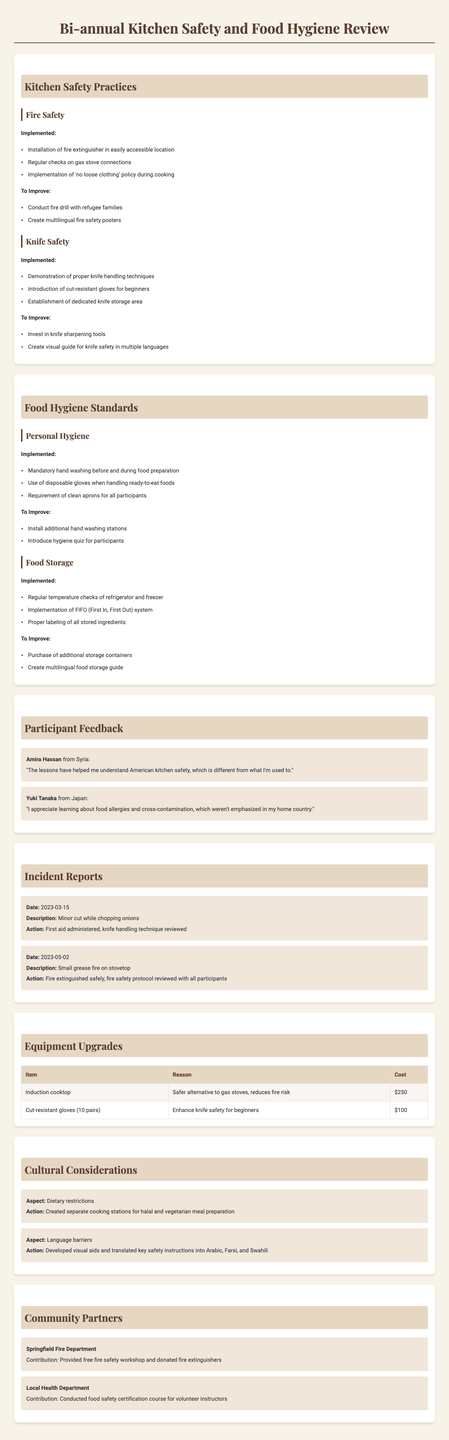What are the implemented fire safety practices? The implemented fire safety practices are listed under the Fire Safety category in the document.
Answer: Installation of fire extinguisher in easily accessible location, Regular checks on gas stove connections, Implementation of 'no loose clothing' policy during cooking What is one of the suggestions to improve knife safety? The suggestions to improve knife safety involve recommendations made in the Knife Safety section of the document.
Answer: Invest in knife sharpening tools How many incident reports are mentioned in the document? The document lists the number of incident reports under the Incident Reports section.
Answer: 2 What did Amira Hassan comment on the cooking lessons? The participant feedback section contains comments from individuals regarding their experience in the lessons.
Answer: The lessons have helped me understand American kitchen safety, which is different from what I'm used to What is the cost of the induction cooktop? The cost of equipment upgrades is shown in the Equipment Upgrades section.
Answer: $250 